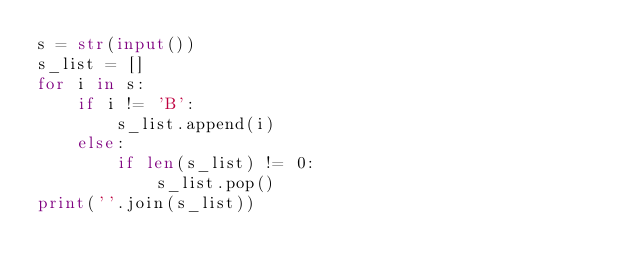Convert code to text. <code><loc_0><loc_0><loc_500><loc_500><_Python_>s = str(input())
s_list = []
for i in s:
	if i != 'B':
		s_list.append(i)
	else:
		if len(s_list) != 0:
			s_list.pop()
print(''.join(s_list))</code> 